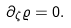<formula> <loc_0><loc_0><loc_500><loc_500>\partial _ { \zeta } \varrho = 0 .</formula> 